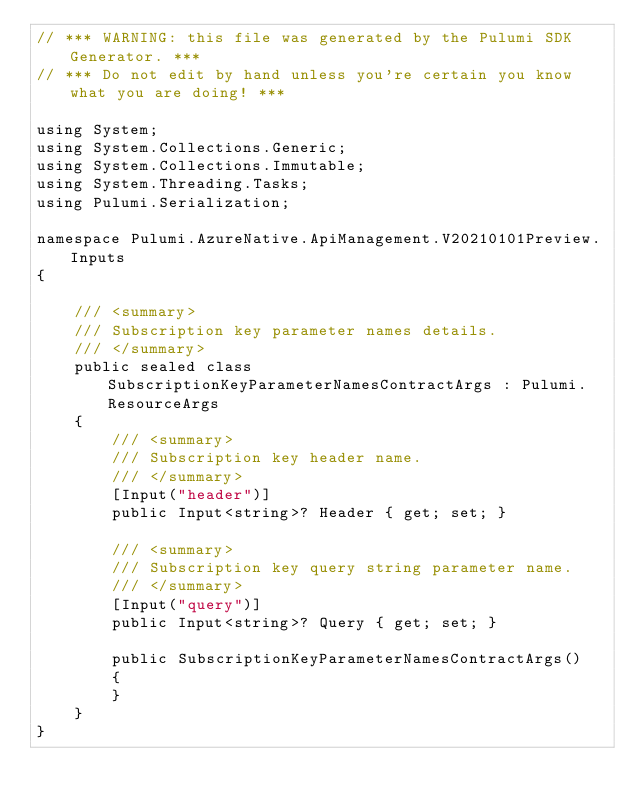Convert code to text. <code><loc_0><loc_0><loc_500><loc_500><_C#_>// *** WARNING: this file was generated by the Pulumi SDK Generator. ***
// *** Do not edit by hand unless you're certain you know what you are doing! ***

using System;
using System.Collections.Generic;
using System.Collections.Immutable;
using System.Threading.Tasks;
using Pulumi.Serialization;

namespace Pulumi.AzureNative.ApiManagement.V20210101Preview.Inputs
{

    /// <summary>
    /// Subscription key parameter names details.
    /// </summary>
    public sealed class SubscriptionKeyParameterNamesContractArgs : Pulumi.ResourceArgs
    {
        /// <summary>
        /// Subscription key header name.
        /// </summary>
        [Input("header")]
        public Input<string>? Header { get; set; }

        /// <summary>
        /// Subscription key query string parameter name.
        /// </summary>
        [Input("query")]
        public Input<string>? Query { get; set; }

        public SubscriptionKeyParameterNamesContractArgs()
        {
        }
    }
}
</code> 